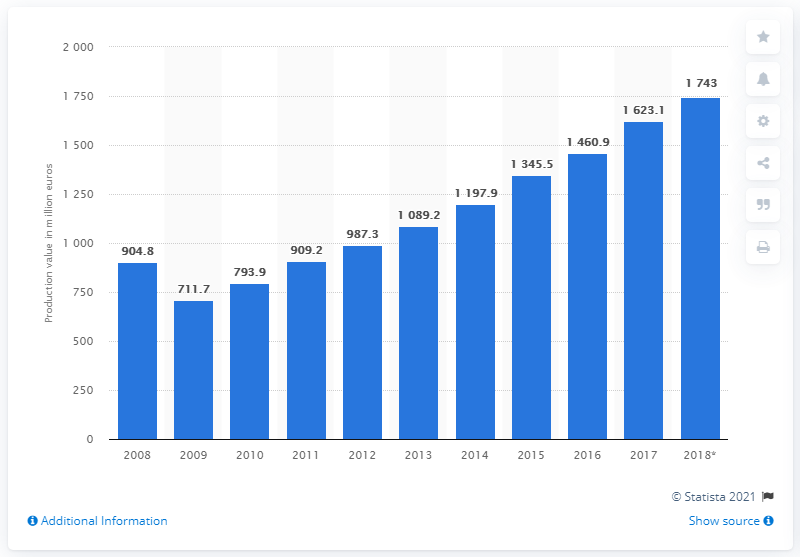Outline some significant characteristics in this image. The annual production value of Bulgaria's manufacturing sector of rubber and plastic products in 2017 was approximately 1623.1 